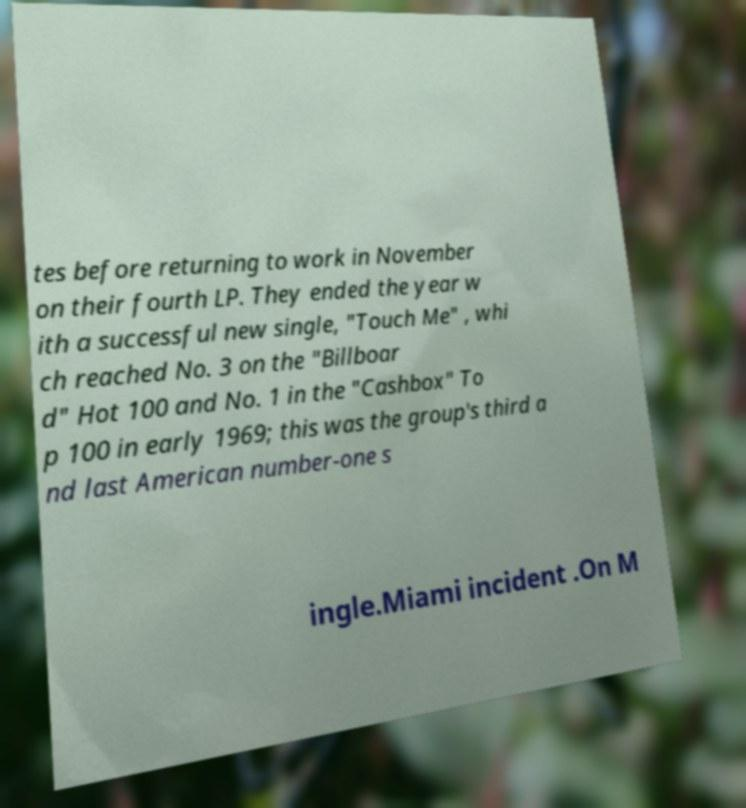Can you accurately transcribe the text from the provided image for me? tes before returning to work in November on their fourth LP. They ended the year w ith a successful new single, "Touch Me" , whi ch reached No. 3 on the "Billboar d" Hot 100 and No. 1 in the "Cashbox" To p 100 in early 1969; this was the group's third a nd last American number-one s ingle.Miami incident .On M 